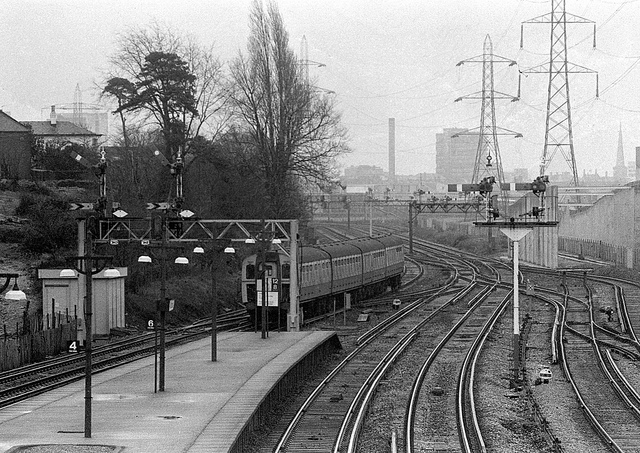Please identify all text content in this image. 4 6 